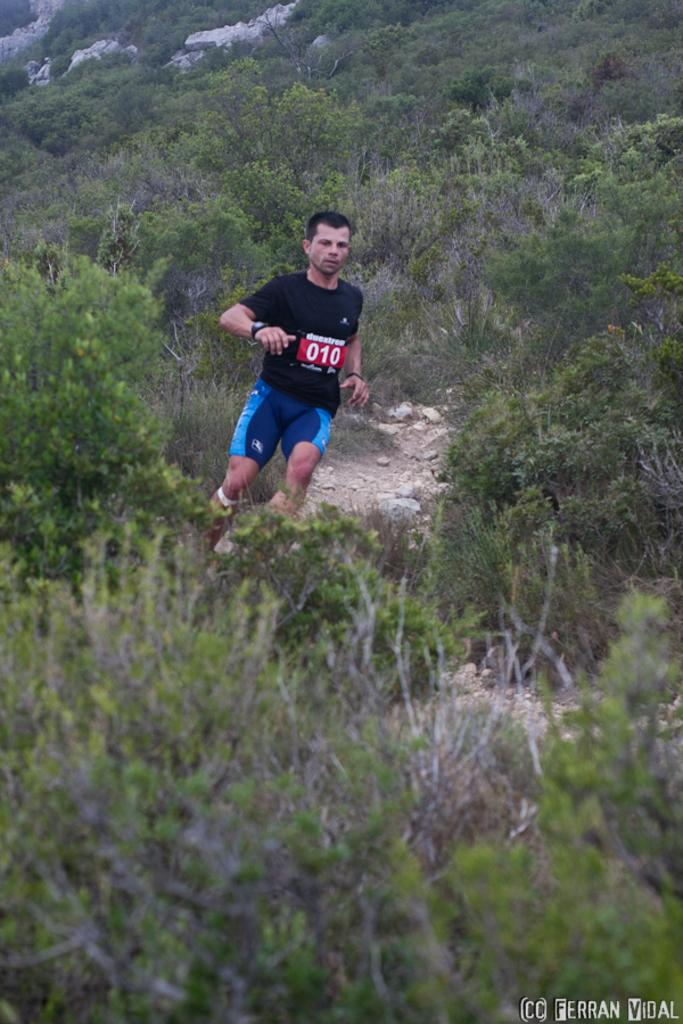Who or what is the main subject of the image? There is a person in the image. What can be seen on the person's clothing? The person is wearing a chest number. What accessory is the person wearing on their wrist? The person is wearing a watch. What activity is the person engaged in? The person is running. What type of natural environment is visible in the image? There are many trees in the image. Is there any text or logo visible in the image? Yes, there is a watermark in the right bottom corner of the image. How many cakes are being served on the desk in the image? There are no cakes or desks present in the image; it features a person running in a natural environment. What type of lead is being used by the person in the image? There is no mention of any lead or similar material in the image; the person is wearing a chest number and a watch. 